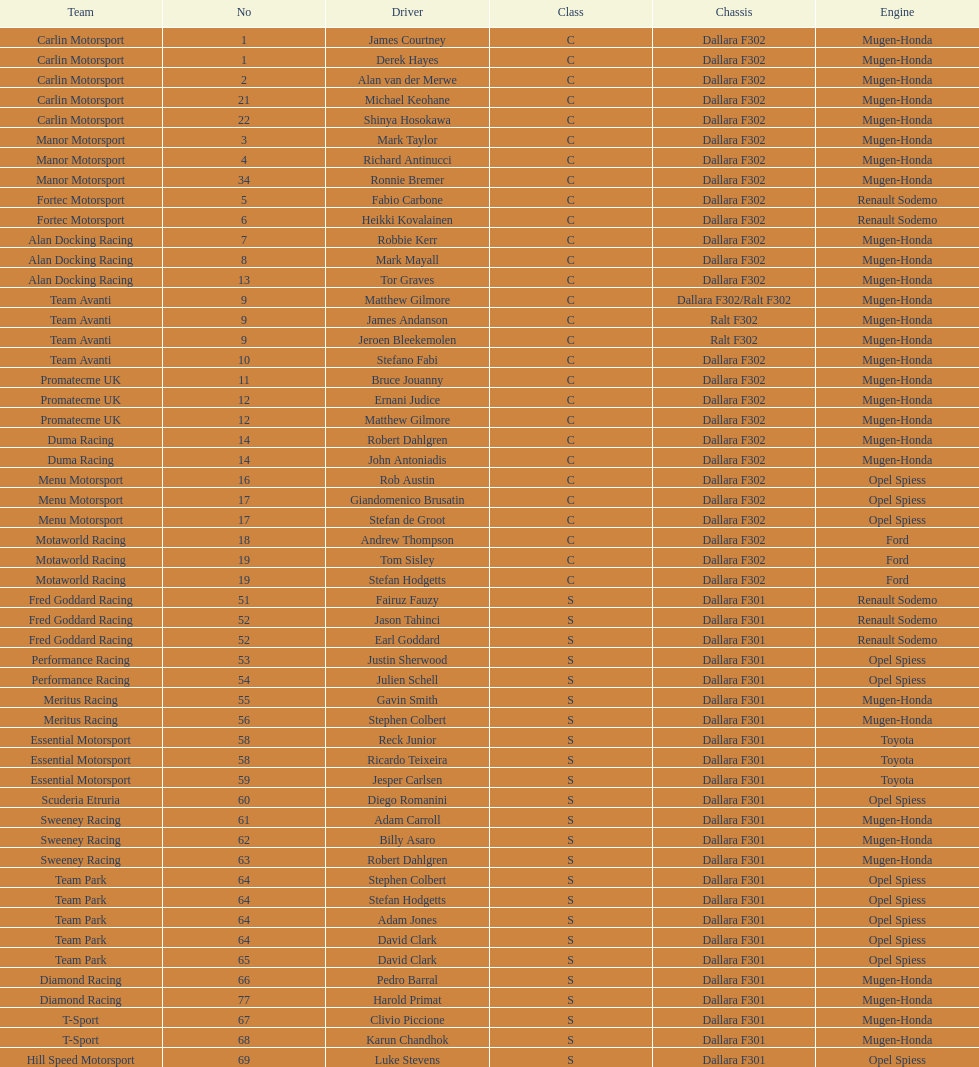Who had a greater number of drivers, team avanti or motaworld racing? Team Avanti. 